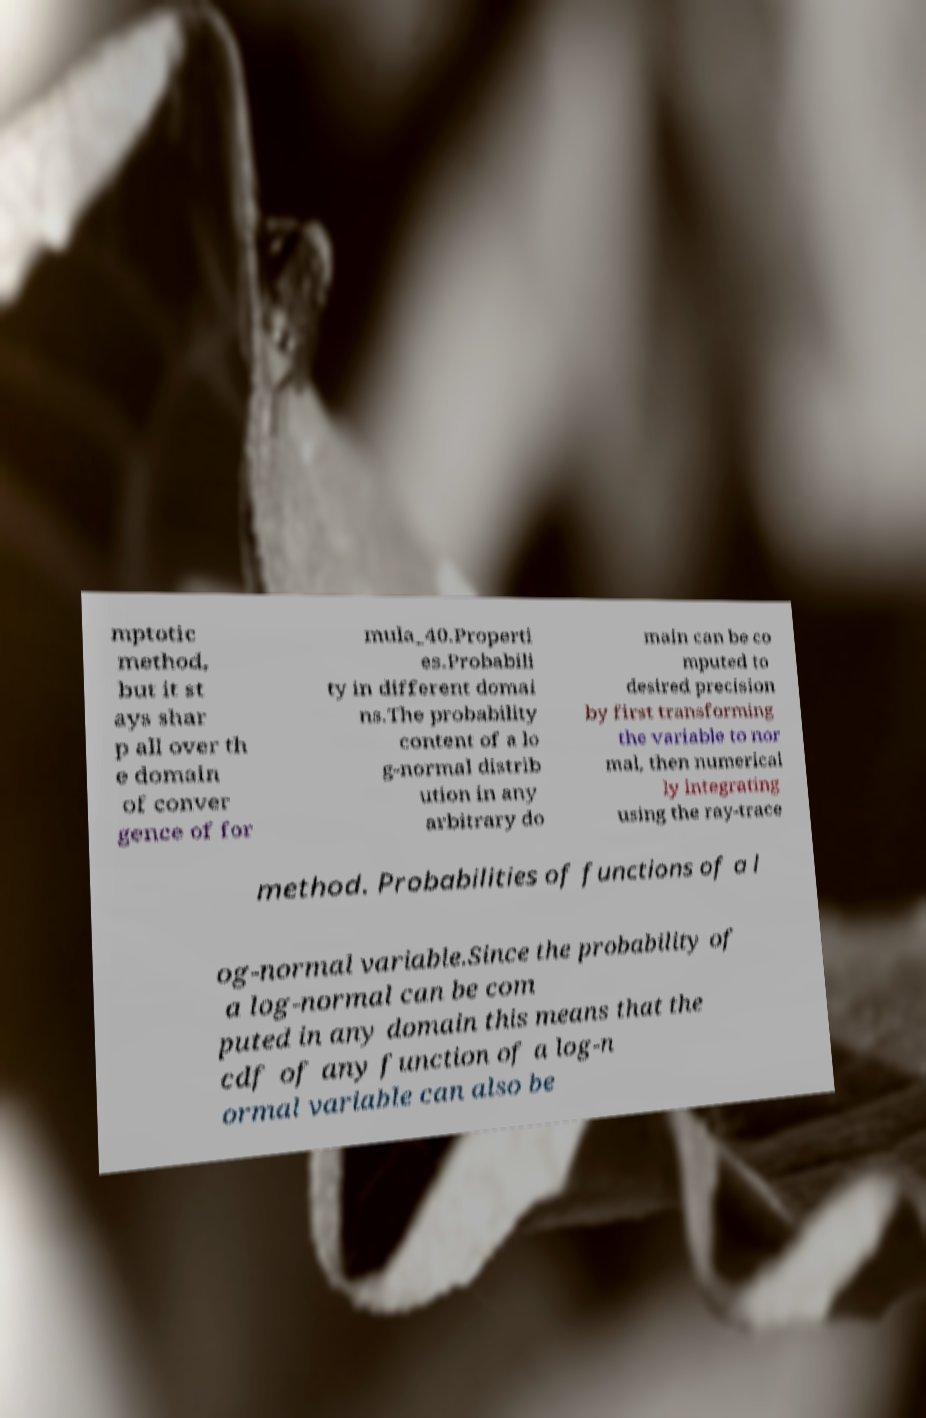Could you assist in decoding the text presented in this image and type it out clearly? mptotic method, but it st ays shar p all over th e domain of conver gence of for mula_40.Properti es.Probabili ty in different domai ns.The probability content of a lo g-normal distrib ution in any arbitrary do main can be co mputed to desired precision by first transforming the variable to nor mal, then numerical ly integrating using the ray-trace method. Probabilities of functions of a l og-normal variable.Since the probability of a log-normal can be com puted in any domain this means that the cdf of any function of a log-n ormal variable can also be 